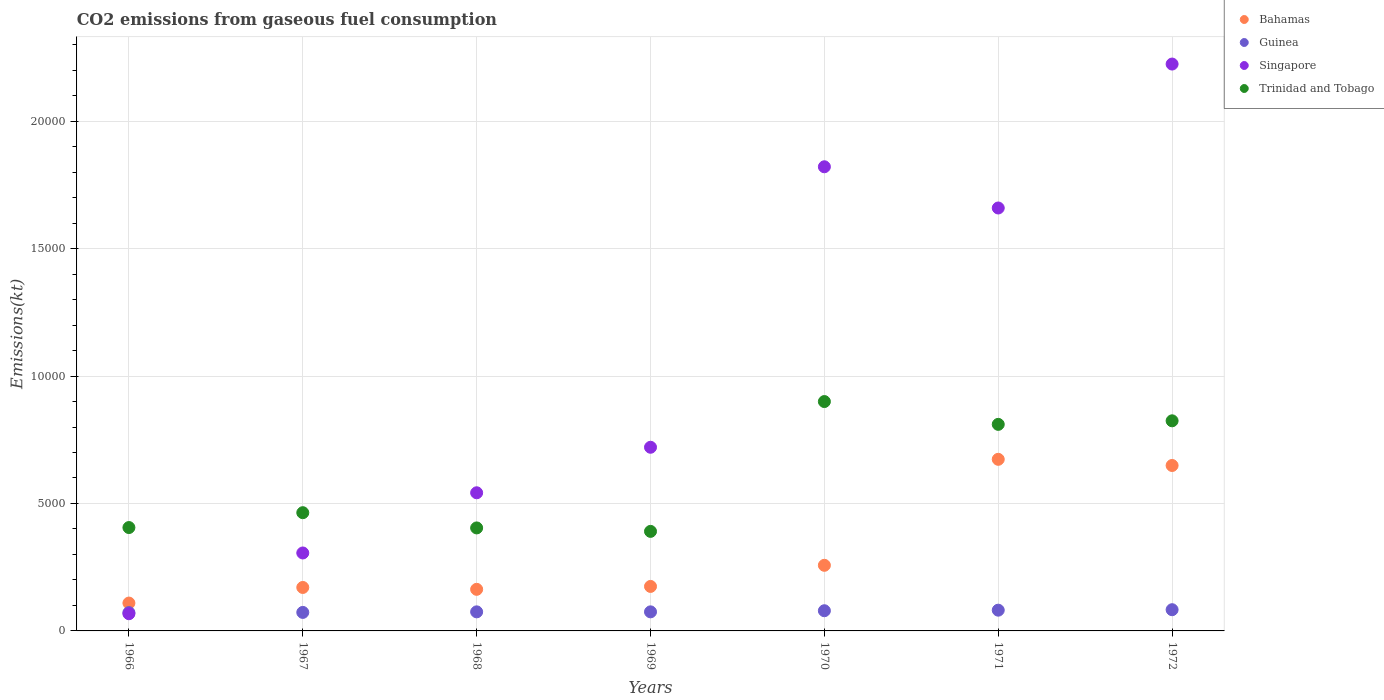How many different coloured dotlines are there?
Offer a very short reply. 4. Is the number of dotlines equal to the number of legend labels?
Offer a very short reply. Yes. What is the amount of CO2 emitted in Trinidad and Tobago in 1971?
Ensure brevity in your answer.  8104.07. Across all years, what is the maximum amount of CO2 emitted in Singapore?
Your answer should be compact. 2.22e+04. Across all years, what is the minimum amount of CO2 emitted in Singapore?
Ensure brevity in your answer.  674.73. In which year was the amount of CO2 emitted in Trinidad and Tobago minimum?
Provide a short and direct response. 1969. What is the total amount of CO2 emitted in Trinidad and Tobago in the graph?
Give a very brief answer. 4.20e+04. What is the difference between the amount of CO2 emitted in Bahamas in 1966 and that in 1971?
Give a very brief answer. -5639.85. What is the difference between the amount of CO2 emitted in Guinea in 1969 and the amount of CO2 emitted in Bahamas in 1967?
Give a very brief answer. -957.09. What is the average amount of CO2 emitted in Trinidad and Tobago per year?
Give a very brief answer. 5998.16. In the year 1970, what is the difference between the amount of CO2 emitted in Guinea and amount of CO2 emitted in Trinidad and Tobago?
Give a very brief answer. -8206.75. In how many years, is the amount of CO2 emitted in Bahamas greater than 19000 kt?
Your answer should be very brief. 0. What is the ratio of the amount of CO2 emitted in Guinea in 1966 to that in 1967?
Your response must be concise. 0.99. Is the amount of CO2 emitted in Trinidad and Tobago in 1968 less than that in 1970?
Give a very brief answer. Yes. Is the difference between the amount of CO2 emitted in Guinea in 1969 and 1971 greater than the difference between the amount of CO2 emitted in Trinidad and Tobago in 1969 and 1971?
Your answer should be very brief. Yes. What is the difference between the highest and the second highest amount of CO2 emitted in Trinidad and Tobago?
Ensure brevity in your answer.  755.4. What is the difference between the highest and the lowest amount of CO2 emitted in Singapore?
Provide a succinct answer. 2.16e+04. In how many years, is the amount of CO2 emitted in Guinea greater than the average amount of CO2 emitted in Guinea taken over all years?
Keep it short and to the point. 3. Is the sum of the amount of CO2 emitted in Singapore in 1970 and 1972 greater than the maximum amount of CO2 emitted in Trinidad and Tobago across all years?
Your response must be concise. Yes. Is it the case that in every year, the sum of the amount of CO2 emitted in Guinea and amount of CO2 emitted in Trinidad and Tobago  is greater than the sum of amount of CO2 emitted in Bahamas and amount of CO2 emitted in Singapore?
Your answer should be very brief. No. Is it the case that in every year, the sum of the amount of CO2 emitted in Bahamas and amount of CO2 emitted in Guinea  is greater than the amount of CO2 emitted in Singapore?
Ensure brevity in your answer.  No. Does the amount of CO2 emitted in Guinea monotonically increase over the years?
Make the answer very short. No. Is the amount of CO2 emitted in Trinidad and Tobago strictly greater than the amount of CO2 emitted in Bahamas over the years?
Your response must be concise. Yes. How many years are there in the graph?
Keep it short and to the point. 7. Does the graph contain grids?
Offer a terse response. Yes. Where does the legend appear in the graph?
Provide a short and direct response. Top right. What is the title of the graph?
Ensure brevity in your answer.  CO2 emissions from gaseous fuel consumption. Does "Sub-Saharan Africa (all income levels)" appear as one of the legend labels in the graph?
Provide a short and direct response. No. What is the label or title of the X-axis?
Make the answer very short. Years. What is the label or title of the Y-axis?
Your answer should be very brief. Emissions(kt). What is the Emissions(kt) in Bahamas in 1966?
Your answer should be compact. 1092.77. What is the Emissions(kt) in Guinea in 1966?
Your answer should be very brief. 718.73. What is the Emissions(kt) of Singapore in 1966?
Ensure brevity in your answer.  674.73. What is the Emissions(kt) of Trinidad and Tobago in 1966?
Ensure brevity in your answer.  4055.7. What is the Emissions(kt) in Bahamas in 1967?
Provide a succinct answer. 1705.15. What is the Emissions(kt) of Guinea in 1967?
Ensure brevity in your answer.  726.07. What is the Emissions(kt) of Singapore in 1967?
Make the answer very short. 3058.28. What is the Emissions(kt) of Trinidad and Tobago in 1967?
Offer a terse response. 4638.76. What is the Emissions(kt) in Bahamas in 1968?
Your answer should be very brief. 1631.82. What is the Emissions(kt) in Guinea in 1968?
Your answer should be very brief. 748.07. What is the Emissions(kt) of Singapore in 1968?
Your answer should be compact. 5419.83. What is the Emissions(kt) in Trinidad and Tobago in 1968?
Your response must be concise. 4041.03. What is the Emissions(kt) in Bahamas in 1969?
Offer a very short reply. 1745.49. What is the Emissions(kt) of Guinea in 1969?
Make the answer very short. 748.07. What is the Emissions(kt) in Singapore in 1969?
Ensure brevity in your answer.  7205.65. What is the Emissions(kt) of Trinidad and Tobago in 1969?
Provide a succinct answer. 3905.36. What is the Emissions(kt) of Bahamas in 1970?
Offer a terse response. 2574.23. What is the Emissions(kt) in Guinea in 1970?
Offer a very short reply. 792.07. What is the Emissions(kt) in Singapore in 1970?
Your response must be concise. 1.82e+04. What is the Emissions(kt) of Trinidad and Tobago in 1970?
Provide a short and direct response. 8998.82. What is the Emissions(kt) of Bahamas in 1971?
Your answer should be compact. 6732.61. What is the Emissions(kt) of Guinea in 1971?
Your answer should be very brief. 814.07. What is the Emissions(kt) in Singapore in 1971?
Offer a terse response. 1.66e+04. What is the Emissions(kt) of Trinidad and Tobago in 1971?
Make the answer very short. 8104.07. What is the Emissions(kt) in Bahamas in 1972?
Provide a short and direct response. 6490.59. What is the Emissions(kt) in Guinea in 1972?
Give a very brief answer. 832.41. What is the Emissions(kt) of Singapore in 1972?
Provide a short and direct response. 2.22e+04. What is the Emissions(kt) of Trinidad and Tobago in 1972?
Ensure brevity in your answer.  8243.42. Across all years, what is the maximum Emissions(kt) of Bahamas?
Your answer should be compact. 6732.61. Across all years, what is the maximum Emissions(kt) of Guinea?
Provide a succinct answer. 832.41. Across all years, what is the maximum Emissions(kt) in Singapore?
Offer a terse response. 2.22e+04. Across all years, what is the maximum Emissions(kt) of Trinidad and Tobago?
Provide a succinct answer. 8998.82. Across all years, what is the minimum Emissions(kt) of Bahamas?
Ensure brevity in your answer.  1092.77. Across all years, what is the minimum Emissions(kt) of Guinea?
Offer a terse response. 718.73. Across all years, what is the minimum Emissions(kt) of Singapore?
Your answer should be compact. 674.73. Across all years, what is the minimum Emissions(kt) of Trinidad and Tobago?
Make the answer very short. 3905.36. What is the total Emissions(kt) of Bahamas in the graph?
Keep it short and to the point. 2.20e+04. What is the total Emissions(kt) in Guinea in the graph?
Offer a very short reply. 5379.49. What is the total Emissions(kt) in Singapore in the graph?
Make the answer very short. 7.34e+04. What is the total Emissions(kt) of Trinidad and Tobago in the graph?
Offer a terse response. 4.20e+04. What is the difference between the Emissions(kt) of Bahamas in 1966 and that in 1967?
Offer a terse response. -612.39. What is the difference between the Emissions(kt) in Guinea in 1966 and that in 1967?
Provide a short and direct response. -7.33. What is the difference between the Emissions(kt) in Singapore in 1966 and that in 1967?
Offer a terse response. -2383.55. What is the difference between the Emissions(kt) of Trinidad and Tobago in 1966 and that in 1967?
Your answer should be compact. -583.05. What is the difference between the Emissions(kt) in Bahamas in 1966 and that in 1968?
Offer a terse response. -539.05. What is the difference between the Emissions(kt) of Guinea in 1966 and that in 1968?
Offer a very short reply. -29.34. What is the difference between the Emissions(kt) of Singapore in 1966 and that in 1968?
Provide a short and direct response. -4745.1. What is the difference between the Emissions(kt) of Trinidad and Tobago in 1966 and that in 1968?
Provide a succinct answer. 14.67. What is the difference between the Emissions(kt) of Bahamas in 1966 and that in 1969?
Provide a short and direct response. -652.73. What is the difference between the Emissions(kt) in Guinea in 1966 and that in 1969?
Ensure brevity in your answer.  -29.34. What is the difference between the Emissions(kt) in Singapore in 1966 and that in 1969?
Your answer should be very brief. -6530.93. What is the difference between the Emissions(kt) of Trinidad and Tobago in 1966 and that in 1969?
Give a very brief answer. 150.35. What is the difference between the Emissions(kt) in Bahamas in 1966 and that in 1970?
Offer a very short reply. -1481.47. What is the difference between the Emissions(kt) of Guinea in 1966 and that in 1970?
Give a very brief answer. -73.34. What is the difference between the Emissions(kt) in Singapore in 1966 and that in 1970?
Provide a succinct answer. -1.75e+04. What is the difference between the Emissions(kt) of Trinidad and Tobago in 1966 and that in 1970?
Ensure brevity in your answer.  -4943.12. What is the difference between the Emissions(kt) of Bahamas in 1966 and that in 1971?
Make the answer very short. -5639.85. What is the difference between the Emissions(kt) in Guinea in 1966 and that in 1971?
Keep it short and to the point. -95.34. What is the difference between the Emissions(kt) in Singapore in 1966 and that in 1971?
Offer a very short reply. -1.59e+04. What is the difference between the Emissions(kt) in Trinidad and Tobago in 1966 and that in 1971?
Ensure brevity in your answer.  -4048.37. What is the difference between the Emissions(kt) in Bahamas in 1966 and that in 1972?
Offer a very short reply. -5397.82. What is the difference between the Emissions(kt) in Guinea in 1966 and that in 1972?
Ensure brevity in your answer.  -113.68. What is the difference between the Emissions(kt) in Singapore in 1966 and that in 1972?
Your response must be concise. -2.16e+04. What is the difference between the Emissions(kt) in Trinidad and Tobago in 1966 and that in 1972?
Your answer should be compact. -4187.71. What is the difference between the Emissions(kt) in Bahamas in 1967 and that in 1968?
Ensure brevity in your answer.  73.34. What is the difference between the Emissions(kt) of Guinea in 1967 and that in 1968?
Provide a short and direct response. -22. What is the difference between the Emissions(kt) of Singapore in 1967 and that in 1968?
Your answer should be very brief. -2361.55. What is the difference between the Emissions(kt) in Trinidad and Tobago in 1967 and that in 1968?
Your answer should be very brief. 597.72. What is the difference between the Emissions(kt) of Bahamas in 1967 and that in 1969?
Make the answer very short. -40.34. What is the difference between the Emissions(kt) of Guinea in 1967 and that in 1969?
Offer a very short reply. -22. What is the difference between the Emissions(kt) of Singapore in 1967 and that in 1969?
Make the answer very short. -4147.38. What is the difference between the Emissions(kt) of Trinidad and Tobago in 1967 and that in 1969?
Your response must be concise. 733.4. What is the difference between the Emissions(kt) in Bahamas in 1967 and that in 1970?
Give a very brief answer. -869.08. What is the difference between the Emissions(kt) of Guinea in 1967 and that in 1970?
Your answer should be very brief. -66.01. What is the difference between the Emissions(kt) in Singapore in 1967 and that in 1970?
Offer a very short reply. -1.52e+04. What is the difference between the Emissions(kt) in Trinidad and Tobago in 1967 and that in 1970?
Provide a short and direct response. -4360.06. What is the difference between the Emissions(kt) in Bahamas in 1967 and that in 1971?
Provide a succinct answer. -5027.46. What is the difference between the Emissions(kt) in Guinea in 1967 and that in 1971?
Ensure brevity in your answer.  -88.01. What is the difference between the Emissions(kt) in Singapore in 1967 and that in 1971?
Your response must be concise. -1.35e+04. What is the difference between the Emissions(kt) of Trinidad and Tobago in 1967 and that in 1971?
Your answer should be very brief. -3465.32. What is the difference between the Emissions(kt) in Bahamas in 1967 and that in 1972?
Provide a short and direct response. -4785.44. What is the difference between the Emissions(kt) in Guinea in 1967 and that in 1972?
Your response must be concise. -106.34. What is the difference between the Emissions(kt) of Singapore in 1967 and that in 1972?
Provide a short and direct response. -1.92e+04. What is the difference between the Emissions(kt) of Trinidad and Tobago in 1967 and that in 1972?
Give a very brief answer. -3604.66. What is the difference between the Emissions(kt) in Bahamas in 1968 and that in 1969?
Make the answer very short. -113.68. What is the difference between the Emissions(kt) in Guinea in 1968 and that in 1969?
Keep it short and to the point. 0. What is the difference between the Emissions(kt) of Singapore in 1968 and that in 1969?
Ensure brevity in your answer.  -1785.83. What is the difference between the Emissions(kt) in Trinidad and Tobago in 1968 and that in 1969?
Keep it short and to the point. 135.68. What is the difference between the Emissions(kt) in Bahamas in 1968 and that in 1970?
Your answer should be compact. -942.42. What is the difference between the Emissions(kt) in Guinea in 1968 and that in 1970?
Keep it short and to the point. -44. What is the difference between the Emissions(kt) in Singapore in 1968 and that in 1970?
Your response must be concise. -1.28e+04. What is the difference between the Emissions(kt) of Trinidad and Tobago in 1968 and that in 1970?
Your answer should be compact. -4957.78. What is the difference between the Emissions(kt) in Bahamas in 1968 and that in 1971?
Your answer should be compact. -5100.8. What is the difference between the Emissions(kt) in Guinea in 1968 and that in 1971?
Make the answer very short. -66.01. What is the difference between the Emissions(kt) of Singapore in 1968 and that in 1971?
Your answer should be very brief. -1.12e+04. What is the difference between the Emissions(kt) in Trinidad and Tobago in 1968 and that in 1971?
Make the answer very short. -4063.04. What is the difference between the Emissions(kt) of Bahamas in 1968 and that in 1972?
Your answer should be very brief. -4858.77. What is the difference between the Emissions(kt) of Guinea in 1968 and that in 1972?
Ensure brevity in your answer.  -84.34. What is the difference between the Emissions(kt) of Singapore in 1968 and that in 1972?
Your answer should be very brief. -1.68e+04. What is the difference between the Emissions(kt) of Trinidad and Tobago in 1968 and that in 1972?
Keep it short and to the point. -4202.38. What is the difference between the Emissions(kt) of Bahamas in 1969 and that in 1970?
Give a very brief answer. -828.74. What is the difference between the Emissions(kt) of Guinea in 1969 and that in 1970?
Keep it short and to the point. -44. What is the difference between the Emissions(kt) of Singapore in 1969 and that in 1970?
Your response must be concise. -1.10e+04. What is the difference between the Emissions(kt) in Trinidad and Tobago in 1969 and that in 1970?
Your answer should be compact. -5093.46. What is the difference between the Emissions(kt) of Bahamas in 1969 and that in 1971?
Give a very brief answer. -4987.12. What is the difference between the Emissions(kt) of Guinea in 1969 and that in 1971?
Provide a succinct answer. -66.01. What is the difference between the Emissions(kt) in Singapore in 1969 and that in 1971?
Provide a succinct answer. -9387.52. What is the difference between the Emissions(kt) of Trinidad and Tobago in 1969 and that in 1971?
Offer a very short reply. -4198.72. What is the difference between the Emissions(kt) of Bahamas in 1969 and that in 1972?
Your answer should be compact. -4745.1. What is the difference between the Emissions(kt) of Guinea in 1969 and that in 1972?
Keep it short and to the point. -84.34. What is the difference between the Emissions(kt) of Singapore in 1969 and that in 1972?
Offer a terse response. -1.50e+04. What is the difference between the Emissions(kt) of Trinidad and Tobago in 1969 and that in 1972?
Your response must be concise. -4338.06. What is the difference between the Emissions(kt) of Bahamas in 1970 and that in 1971?
Offer a very short reply. -4158.38. What is the difference between the Emissions(kt) in Guinea in 1970 and that in 1971?
Make the answer very short. -22. What is the difference between the Emissions(kt) of Singapore in 1970 and that in 1971?
Your answer should be very brief. 1617.15. What is the difference between the Emissions(kt) of Trinidad and Tobago in 1970 and that in 1971?
Your answer should be very brief. 894.75. What is the difference between the Emissions(kt) of Bahamas in 1970 and that in 1972?
Your response must be concise. -3916.36. What is the difference between the Emissions(kt) in Guinea in 1970 and that in 1972?
Your response must be concise. -40.34. What is the difference between the Emissions(kt) of Singapore in 1970 and that in 1972?
Ensure brevity in your answer.  -4030.03. What is the difference between the Emissions(kt) of Trinidad and Tobago in 1970 and that in 1972?
Your answer should be compact. 755.4. What is the difference between the Emissions(kt) of Bahamas in 1971 and that in 1972?
Your response must be concise. 242.02. What is the difference between the Emissions(kt) in Guinea in 1971 and that in 1972?
Your answer should be compact. -18.34. What is the difference between the Emissions(kt) in Singapore in 1971 and that in 1972?
Provide a succinct answer. -5647.18. What is the difference between the Emissions(kt) in Trinidad and Tobago in 1971 and that in 1972?
Offer a very short reply. -139.35. What is the difference between the Emissions(kt) of Bahamas in 1966 and the Emissions(kt) of Guinea in 1967?
Make the answer very short. 366.7. What is the difference between the Emissions(kt) in Bahamas in 1966 and the Emissions(kt) in Singapore in 1967?
Provide a short and direct response. -1965.51. What is the difference between the Emissions(kt) in Bahamas in 1966 and the Emissions(kt) in Trinidad and Tobago in 1967?
Ensure brevity in your answer.  -3545.99. What is the difference between the Emissions(kt) in Guinea in 1966 and the Emissions(kt) in Singapore in 1967?
Provide a short and direct response. -2339.55. What is the difference between the Emissions(kt) in Guinea in 1966 and the Emissions(kt) in Trinidad and Tobago in 1967?
Make the answer very short. -3920.02. What is the difference between the Emissions(kt) of Singapore in 1966 and the Emissions(kt) of Trinidad and Tobago in 1967?
Give a very brief answer. -3964.03. What is the difference between the Emissions(kt) of Bahamas in 1966 and the Emissions(kt) of Guinea in 1968?
Make the answer very short. 344.7. What is the difference between the Emissions(kt) in Bahamas in 1966 and the Emissions(kt) in Singapore in 1968?
Offer a very short reply. -4327.06. What is the difference between the Emissions(kt) of Bahamas in 1966 and the Emissions(kt) of Trinidad and Tobago in 1968?
Your answer should be very brief. -2948.27. What is the difference between the Emissions(kt) of Guinea in 1966 and the Emissions(kt) of Singapore in 1968?
Provide a short and direct response. -4701.09. What is the difference between the Emissions(kt) of Guinea in 1966 and the Emissions(kt) of Trinidad and Tobago in 1968?
Your answer should be compact. -3322.3. What is the difference between the Emissions(kt) in Singapore in 1966 and the Emissions(kt) in Trinidad and Tobago in 1968?
Your response must be concise. -3366.31. What is the difference between the Emissions(kt) of Bahamas in 1966 and the Emissions(kt) of Guinea in 1969?
Offer a very short reply. 344.7. What is the difference between the Emissions(kt) in Bahamas in 1966 and the Emissions(kt) in Singapore in 1969?
Your answer should be very brief. -6112.89. What is the difference between the Emissions(kt) of Bahamas in 1966 and the Emissions(kt) of Trinidad and Tobago in 1969?
Your answer should be compact. -2812.59. What is the difference between the Emissions(kt) in Guinea in 1966 and the Emissions(kt) in Singapore in 1969?
Ensure brevity in your answer.  -6486.92. What is the difference between the Emissions(kt) of Guinea in 1966 and the Emissions(kt) of Trinidad and Tobago in 1969?
Offer a terse response. -3186.62. What is the difference between the Emissions(kt) in Singapore in 1966 and the Emissions(kt) in Trinidad and Tobago in 1969?
Your answer should be very brief. -3230.63. What is the difference between the Emissions(kt) of Bahamas in 1966 and the Emissions(kt) of Guinea in 1970?
Your answer should be very brief. 300.69. What is the difference between the Emissions(kt) of Bahamas in 1966 and the Emissions(kt) of Singapore in 1970?
Give a very brief answer. -1.71e+04. What is the difference between the Emissions(kt) of Bahamas in 1966 and the Emissions(kt) of Trinidad and Tobago in 1970?
Ensure brevity in your answer.  -7906.05. What is the difference between the Emissions(kt) in Guinea in 1966 and the Emissions(kt) in Singapore in 1970?
Provide a short and direct response. -1.75e+04. What is the difference between the Emissions(kt) in Guinea in 1966 and the Emissions(kt) in Trinidad and Tobago in 1970?
Offer a very short reply. -8280.09. What is the difference between the Emissions(kt) in Singapore in 1966 and the Emissions(kt) in Trinidad and Tobago in 1970?
Provide a succinct answer. -8324.09. What is the difference between the Emissions(kt) in Bahamas in 1966 and the Emissions(kt) in Guinea in 1971?
Offer a terse response. 278.69. What is the difference between the Emissions(kt) of Bahamas in 1966 and the Emissions(kt) of Singapore in 1971?
Your response must be concise. -1.55e+04. What is the difference between the Emissions(kt) of Bahamas in 1966 and the Emissions(kt) of Trinidad and Tobago in 1971?
Make the answer very short. -7011.3. What is the difference between the Emissions(kt) in Guinea in 1966 and the Emissions(kt) in Singapore in 1971?
Make the answer very short. -1.59e+04. What is the difference between the Emissions(kt) in Guinea in 1966 and the Emissions(kt) in Trinidad and Tobago in 1971?
Keep it short and to the point. -7385.34. What is the difference between the Emissions(kt) in Singapore in 1966 and the Emissions(kt) in Trinidad and Tobago in 1971?
Make the answer very short. -7429.34. What is the difference between the Emissions(kt) in Bahamas in 1966 and the Emissions(kt) in Guinea in 1972?
Provide a succinct answer. 260.36. What is the difference between the Emissions(kt) in Bahamas in 1966 and the Emissions(kt) in Singapore in 1972?
Provide a short and direct response. -2.11e+04. What is the difference between the Emissions(kt) of Bahamas in 1966 and the Emissions(kt) of Trinidad and Tobago in 1972?
Offer a very short reply. -7150.65. What is the difference between the Emissions(kt) in Guinea in 1966 and the Emissions(kt) in Singapore in 1972?
Offer a very short reply. -2.15e+04. What is the difference between the Emissions(kt) of Guinea in 1966 and the Emissions(kt) of Trinidad and Tobago in 1972?
Keep it short and to the point. -7524.68. What is the difference between the Emissions(kt) of Singapore in 1966 and the Emissions(kt) of Trinidad and Tobago in 1972?
Offer a terse response. -7568.69. What is the difference between the Emissions(kt) in Bahamas in 1967 and the Emissions(kt) in Guinea in 1968?
Your answer should be very brief. 957.09. What is the difference between the Emissions(kt) in Bahamas in 1967 and the Emissions(kt) in Singapore in 1968?
Offer a very short reply. -3714.67. What is the difference between the Emissions(kt) of Bahamas in 1967 and the Emissions(kt) of Trinidad and Tobago in 1968?
Keep it short and to the point. -2335.88. What is the difference between the Emissions(kt) in Guinea in 1967 and the Emissions(kt) in Singapore in 1968?
Ensure brevity in your answer.  -4693.76. What is the difference between the Emissions(kt) of Guinea in 1967 and the Emissions(kt) of Trinidad and Tobago in 1968?
Offer a very short reply. -3314.97. What is the difference between the Emissions(kt) in Singapore in 1967 and the Emissions(kt) in Trinidad and Tobago in 1968?
Give a very brief answer. -982.76. What is the difference between the Emissions(kt) in Bahamas in 1967 and the Emissions(kt) in Guinea in 1969?
Your answer should be very brief. 957.09. What is the difference between the Emissions(kt) of Bahamas in 1967 and the Emissions(kt) of Singapore in 1969?
Provide a short and direct response. -5500.5. What is the difference between the Emissions(kt) of Bahamas in 1967 and the Emissions(kt) of Trinidad and Tobago in 1969?
Ensure brevity in your answer.  -2200.2. What is the difference between the Emissions(kt) in Guinea in 1967 and the Emissions(kt) in Singapore in 1969?
Provide a succinct answer. -6479.59. What is the difference between the Emissions(kt) in Guinea in 1967 and the Emissions(kt) in Trinidad and Tobago in 1969?
Offer a very short reply. -3179.29. What is the difference between the Emissions(kt) in Singapore in 1967 and the Emissions(kt) in Trinidad and Tobago in 1969?
Keep it short and to the point. -847.08. What is the difference between the Emissions(kt) of Bahamas in 1967 and the Emissions(kt) of Guinea in 1970?
Ensure brevity in your answer.  913.08. What is the difference between the Emissions(kt) in Bahamas in 1967 and the Emissions(kt) in Singapore in 1970?
Provide a short and direct response. -1.65e+04. What is the difference between the Emissions(kt) in Bahamas in 1967 and the Emissions(kt) in Trinidad and Tobago in 1970?
Your answer should be very brief. -7293.66. What is the difference between the Emissions(kt) in Guinea in 1967 and the Emissions(kt) in Singapore in 1970?
Keep it short and to the point. -1.75e+04. What is the difference between the Emissions(kt) of Guinea in 1967 and the Emissions(kt) of Trinidad and Tobago in 1970?
Give a very brief answer. -8272.75. What is the difference between the Emissions(kt) of Singapore in 1967 and the Emissions(kt) of Trinidad and Tobago in 1970?
Ensure brevity in your answer.  -5940.54. What is the difference between the Emissions(kt) of Bahamas in 1967 and the Emissions(kt) of Guinea in 1971?
Give a very brief answer. 891.08. What is the difference between the Emissions(kt) of Bahamas in 1967 and the Emissions(kt) of Singapore in 1971?
Provide a short and direct response. -1.49e+04. What is the difference between the Emissions(kt) in Bahamas in 1967 and the Emissions(kt) in Trinidad and Tobago in 1971?
Your response must be concise. -6398.91. What is the difference between the Emissions(kt) in Guinea in 1967 and the Emissions(kt) in Singapore in 1971?
Your response must be concise. -1.59e+04. What is the difference between the Emissions(kt) in Guinea in 1967 and the Emissions(kt) in Trinidad and Tobago in 1971?
Offer a terse response. -7378. What is the difference between the Emissions(kt) in Singapore in 1967 and the Emissions(kt) in Trinidad and Tobago in 1971?
Your answer should be very brief. -5045.79. What is the difference between the Emissions(kt) of Bahamas in 1967 and the Emissions(kt) of Guinea in 1972?
Provide a short and direct response. 872.75. What is the difference between the Emissions(kt) of Bahamas in 1967 and the Emissions(kt) of Singapore in 1972?
Offer a very short reply. -2.05e+04. What is the difference between the Emissions(kt) in Bahamas in 1967 and the Emissions(kt) in Trinidad and Tobago in 1972?
Make the answer very short. -6538.26. What is the difference between the Emissions(kt) of Guinea in 1967 and the Emissions(kt) of Singapore in 1972?
Your answer should be very brief. -2.15e+04. What is the difference between the Emissions(kt) in Guinea in 1967 and the Emissions(kt) in Trinidad and Tobago in 1972?
Make the answer very short. -7517.35. What is the difference between the Emissions(kt) of Singapore in 1967 and the Emissions(kt) of Trinidad and Tobago in 1972?
Keep it short and to the point. -5185.14. What is the difference between the Emissions(kt) of Bahamas in 1968 and the Emissions(kt) of Guinea in 1969?
Offer a terse response. 883.75. What is the difference between the Emissions(kt) of Bahamas in 1968 and the Emissions(kt) of Singapore in 1969?
Offer a terse response. -5573.84. What is the difference between the Emissions(kt) of Bahamas in 1968 and the Emissions(kt) of Trinidad and Tobago in 1969?
Make the answer very short. -2273.54. What is the difference between the Emissions(kt) in Guinea in 1968 and the Emissions(kt) in Singapore in 1969?
Provide a short and direct response. -6457.59. What is the difference between the Emissions(kt) of Guinea in 1968 and the Emissions(kt) of Trinidad and Tobago in 1969?
Your answer should be compact. -3157.29. What is the difference between the Emissions(kt) in Singapore in 1968 and the Emissions(kt) in Trinidad and Tobago in 1969?
Provide a short and direct response. 1514.47. What is the difference between the Emissions(kt) of Bahamas in 1968 and the Emissions(kt) of Guinea in 1970?
Your response must be concise. 839.74. What is the difference between the Emissions(kt) in Bahamas in 1968 and the Emissions(kt) in Singapore in 1970?
Your response must be concise. -1.66e+04. What is the difference between the Emissions(kt) in Bahamas in 1968 and the Emissions(kt) in Trinidad and Tobago in 1970?
Provide a short and direct response. -7367. What is the difference between the Emissions(kt) in Guinea in 1968 and the Emissions(kt) in Singapore in 1970?
Make the answer very short. -1.75e+04. What is the difference between the Emissions(kt) in Guinea in 1968 and the Emissions(kt) in Trinidad and Tobago in 1970?
Make the answer very short. -8250.75. What is the difference between the Emissions(kt) of Singapore in 1968 and the Emissions(kt) of Trinidad and Tobago in 1970?
Ensure brevity in your answer.  -3578.99. What is the difference between the Emissions(kt) in Bahamas in 1968 and the Emissions(kt) in Guinea in 1971?
Ensure brevity in your answer.  817.74. What is the difference between the Emissions(kt) of Bahamas in 1968 and the Emissions(kt) of Singapore in 1971?
Provide a succinct answer. -1.50e+04. What is the difference between the Emissions(kt) in Bahamas in 1968 and the Emissions(kt) in Trinidad and Tobago in 1971?
Provide a succinct answer. -6472.26. What is the difference between the Emissions(kt) of Guinea in 1968 and the Emissions(kt) of Singapore in 1971?
Give a very brief answer. -1.58e+04. What is the difference between the Emissions(kt) of Guinea in 1968 and the Emissions(kt) of Trinidad and Tobago in 1971?
Keep it short and to the point. -7356. What is the difference between the Emissions(kt) in Singapore in 1968 and the Emissions(kt) in Trinidad and Tobago in 1971?
Make the answer very short. -2684.24. What is the difference between the Emissions(kt) in Bahamas in 1968 and the Emissions(kt) in Guinea in 1972?
Your answer should be very brief. 799.41. What is the difference between the Emissions(kt) of Bahamas in 1968 and the Emissions(kt) of Singapore in 1972?
Give a very brief answer. -2.06e+04. What is the difference between the Emissions(kt) of Bahamas in 1968 and the Emissions(kt) of Trinidad and Tobago in 1972?
Make the answer very short. -6611.6. What is the difference between the Emissions(kt) of Guinea in 1968 and the Emissions(kt) of Singapore in 1972?
Keep it short and to the point. -2.15e+04. What is the difference between the Emissions(kt) in Guinea in 1968 and the Emissions(kt) in Trinidad and Tobago in 1972?
Provide a succinct answer. -7495.35. What is the difference between the Emissions(kt) of Singapore in 1968 and the Emissions(kt) of Trinidad and Tobago in 1972?
Offer a terse response. -2823.59. What is the difference between the Emissions(kt) of Bahamas in 1969 and the Emissions(kt) of Guinea in 1970?
Keep it short and to the point. 953.42. What is the difference between the Emissions(kt) of Bahamas in 1969 and the Emissions(kt) of Singapore in 1970?
Keep it short and to the point. -1.65e+04. What is the difference between the Emissions(kt) in Bahamas in 1969 and the Emissions(kt) in Trinidad and Tobago in 1970?
Make the answer very short. -7253.33. What is the difference between the Emissions(kt) in Guinea in 1969 and the Emissions(kt) in Singapore in 1970?
Offer a very short reply. -1.75e+04. What is the difference between the Emissions(kt) of Guinea in 1969 and the Emissions(kt) of Trinidad and Tobago in 1970?
Ensure brevity in your answer.  -8250.75. What is the difference between the Emissions(kt) in Singapore in 1969 and the Emissions(kt) in Trinidad and Tobago in 1970?
Keep it short and to the point. -1793.16. What is the difference between the Emissions(kt) in Bahamas in 1969 and the Emissions(kt) in Guinea in 1971?
Ensure brevity in your answer.  931.42. What is the difference between the Emissions(kt) of Bahamas in 1969 and the Emissions(kt) of Singapore in 1971?
Offer a terse response. -1.48e+04. What is the difference between the Emissions(kt) in Bahamas in 1969 and the Emissions(kt) in Trinidad and Tobago in 1971?
Offer a very short reply. -6358.58. What is the difference between the Emissions(kt) of Guinea in 1969 and the Emissions(kt) of Singapore in 1971?
Make the answer very short. -1.58e+04. What is the difference between the Emissions(kt) in Guinea in 1969 and the Emissions(kt) in Trinidad and Tobago in 1971?
Provide a short and direct response. -7356. What is the difference between the Emissions(kt) in Singapore in 1969 and the Emissions(kt) in Trinidad and Tobago in 1971?
Your response must be concise. -898.41. What is the difference between the Emissions(kt) in Bahamas in 1969 and the Emissions(kt) in Guinea in 1972?
Give a very brief answer. 913.08. What is the difference between the Emissions(kt) of Bahamas in 1969 and the Emissions(kt) of Singapore in 1972?
Ensure brevity in your answer.  -2.05e+04. What is the difference between the Emissions(kt) in Bahamas in 1969 and the Emissions(kt) in Trinidad and Tobago in 1972?
Offer a very short reply. -6497.92. What is the difference between the Emissions(kt) of Guinea in 1969 and the Emissions(kt) of Singapore in 1972?
Make the answer very short. -2.15e+04. What is the difference between the Emissions(kt) of Guinea in 1969 and the Emissions(kt) of Trinidad and Tobago in 1972?
Your answer should be very brief. -7495.35. What is the difference between the Emissions(kt) in Singapore in 1969 and the Emissions(kt) in Trinidad and Tobago in 1972?
Your response must be concise. -1037.76. What is the difference between the Emissions(kt) in Bahamas in 1970 and the Emissions(kt) in Guinea in 1971?
Offer a terse response. 1760.16. What is the difference between the Emissions(kt) in Bahamas in 1970 and the Emissions(kt) in Singapore in 1971?
Make the answer very short. -1.40e+04. What is the difference between the Emissions(kt) of Bahamas in 1970 and the Emissions(kt) of Trinidad and Tobago in 1971?
Offer a very short reply. -5529.84. What is the difference between the Emissions(kt) of Guinea in 1970 and the Emissions(kt) of Singapore in 1971?
Offer a terse response. -1.58e+04. What is the difference between the Emissions(kt) of Guinea in 1970 and the Emissions(kt) of Trinidad and Tobago in 1971?
Offer a very short reply. -7312. What is the difference between the Emissions(kt) in Singapore in 1970 and the Emissions(kt) in Trinidad and Tobago in 1971?
Make the answer very short. 1.01e+04. What is the difference between the Emissions(kt) of Bahamas in 1970 and the Emissions(kt) of Guinea in 1972?
Ensure brevity in your answer.  1741.83. What is the difference between the Emissions(kt) of Bahamas in 1970 and the Emissions(kt) of Singapore in 1972?
Offer a very short reply. -1.97e+04. What is the difference between the Emissions(kt) of Bahamas in 1970 and the Emissions(kt) of Trinidad and Tobago in 1972?
Offer a very short reply. -5669.18. What is the difference between the Emissions(kt) of Guinea in 1970 and the Emissions(kt) of Singapore in 1972?
Your response must be concise. -2.14e+04. What is the difference between the Emissions(kt) of Guinea in 1970 and the Emissions(kt) of Trinidad and Tobago in 1972?
Provide a short and direct response. -7451.34. What is the difference between the Emissions(kt) in Singapore in 1970 and the Emissions(kt) in Trinidad and Tobago in 1972?
Provide a short and direct response. 9966.91. What is the difference between the Emissions(kt) in Bahamas in 1971 and the Emissions(kt) in Guinea in 1972?
Give a very brief answer. 5900.2. What is the difference between the Emissions(kt) in Bahamas in 1971 and the Emissions(kt) in Singapore in 1972?
Keep it short and to the point. -1.55e+04. What is the difference between the Emissions(kt) in Bahamas in 1971 and the Emissions(kt) in Trinidad and Tobago in 1972?
Provide a short and direct response. -1510.8. What is the difference between the Emissions(kt) in Guinea in 1971 and the Emissions(kt) in Singapore in 1972?
Provide a succinct answer. -2.14e+04. What is the difference between the Emissions(kt) in Guinea in 1971 and the Emissions(kt) in Trinidad and Tobago in 1972?
Your answer should be compact. -7429.34. What is the difference between the Emissions(kt) of Singapore in 1971 and the Emissions(kt) of Trinidad and Tobago in 1972?
Ensure brevity in your answer.  8349.76. What is the average Emissions(kt) in Bahamas per year?
Give a very brief answer. 3138.95. What is the average Emissions(kt) in Guinea per year?
Offer a terse response. 768.5. What is the average Emissions(kt) of Singapore per year?
Offer a terse response. 1.05e+04. What is the average Emissions(kt) of Trinidad and Tobago per year?
Your response must be concise. 5998.16. In the year 1966, what is the difference between the Emissions(kt) in Bahamas and Emissions(kt) in Guinea?
Ensure brevity in your answer.  374.03. In the year 1966, what is the difference between the Emissions(kt) in Bahamas and Emissions(kt) in Singapore?
Your answer should be compact. 418.04. In the year 1966, what is the difference between the Emissions(kt) of Bahamas and Emissions(kt) of Trinidad and Tobago?
Your answer should be very brief. -2962.94. In the year 1966, what is the difference between the Emissions(kt) of Guinea and Emissions(kt) of Singapore?
Make the answer very short. 44. In the year 1966, what is the difference between the Emissions(kt) in Guinea and Emissions(kt) in Trinidad and Tobago?
Your answer should be very brief. -3336.97. In the year 1966, what is the difference between the Emissions(kt) of Singapore and Emissions(kt) of Trinidad and Tobago?
Make the answer very short. -3380.97. In the year 1967, what is the difference between the Emissions(kt) in Bahamas and Emissions(kt) in Guinea?
Give a very brief answer. 979.09. In the year 1967, what is the difference between the Emissions(kt) of Bahamas and Emissions(kt) of Singapore?
Offer a very short reply. -1353.12. In the year 1967, what is the difference between the Emissions(kt) of Bahamas and Emissions(kt) of Trinidad and Tobago?
Keep it short and to the point. -2933.6. In the year 1967, what is the difference between the Emissions(kt) in Guinea and Emissions(kt) in Singapore?
Provide a short and direct response. -2332.21. In the year 1967, what is the difference between the Emissions(kt) in Guinea and Emissions(kt) in Trinidad and Tobago?
Make the answer very short. -3912.69. In the year 1967, what is the difference between the Emissions(kt) of Singapore and Emissions(kt) of Trinidad and Tobago?
Make the answer very short. -1580.48. In the year 1968, what is the difference between the Emissions(kt) in Bahamas and Emissions(kt) in Guinea?
Provide a succinct answer. 883.75. In the year 1968, what is the difference between the Emissions(kt) in Bahamas and Emissions(kt) in Singapore?
Provide a short and direct response. -3788.01. In the year 1968, what is the difference between the Emissions(kt) of Bahamas and Emissions(kt) of Trinidad and Tobago?
Give a very brief answer. -2409.22. In the year 1968, what is the difference between the Emissions(kt) in Guinea and Emissions(kt) in Singapore?
Provide a short and direct response. -4671.76. In the year 1968, what is the difference between the Emissions(kt) of Guinea and Emissions(kt) of Trinidad and Tobago?
Your answer should be compact. -3292.97. In the year 1968, what is the difference between the Emissions(kt) of Singapore and Emissions(kt) of Trinidad and Tobago?
Offer a terse response. 1378.79. In the year 1969, what is the difference between the Emissions(kt) of Bahamas and Emissions(kt) of Guinea?
Your response must be concise. 997.42. In the year 1969, what is the difference between the Emissions(kt) in Bahamas and Emissions(kt) in Singapore?
Give a very brief answer. -5460.16. In the year 1969, what is the difference between the Emissions(kt) of Bahamas and Emissions(kt) of Trinidad and Tobago?
Ensure brevity in your answer.  -2159.86. In the year 1969, what is the difference between the Emissions(kt) of Guinea and Emissions(kt) of Singapore?
Your response must be concise. -6457.59. In the year 1969, what is the difference between the Emissions(kt) in Guinea and Emissions(kt) in Trinidad and Tobago?
Offer a very short reply. -3157.29. In the year 1969, what is the difference between the Emissions(kt) of Singapore and Emissions(kt) of Trinidad and Tobago?
Your response must be concise. 3300.3. In the year 1970, what is the difference between the Emissions(kt) of Bahamas and Emissions(kt) of Guinea?
Ensure brevity in your answer.  1782.16. In the year 1970, what is the difference between the Emissions(kt) of Bahamas and Emissions(kt) of Singapore?
Your response must be concise. -1.56e+04. In the year 1970, what is the difference between the Emissions(kt) in Bahamas and Emissions(kt) in Trinidad and Tobago?
Your answer should be compact. -6424.58. In the year 1970, what is the difference between the Emissions(kt) of Guinea and Emissions(kt) of Singapore?
Offer a terse response. -1.74e+04. In the year 1970, what is the difference between the Emissions(kt) of Guinea and Emissions(kt) of Trinidad and Tobago?
Provide a succinct answer. -8206.75. In the year 1970, what is the difference between the Emissions(kt) in Singapore and Emissions(kt) in Trinidad and Tobago?
Ensure brevity in your answer.  9211.5. In the year 1971, what is the difference between the Emissions(kt) of Bahamas and Emissions(kt) of Guinea?
Offer a very short reply. 5918.54. In the year 1971, what is the difference between the Emissions(kt) in Bahamas and Emissions(kt) in Singapore?
Give a very brief answer. -9860.56. In the year 1971, what is the difference between the Emissions(kt) of Bahamas and Emissions(kt) of Trinidad and Tobago?
Your answer should be compact. -1371.46. In the year 1971, what is the difference between the Emissions(kt) in Guinea and Emissions(kt) in Singapore?
Make the answer very short. -1.58e+04. In the year 1971, what is the difference between the Emissions(kt) in Guinea and Emissions(kt) in Trinidad and Tobago?
Offer a terse response. -7290. In the year 1971, what is the difference between the Emissions(kt) of Singapore and Emissions(kt) of Trinidad and Tobago?
Offer a very short reply. 8489.1. In the year 1972, what is the difference between the Emissions(kt) of Bahamas and Emissions(kt) of Guinea?
Give a very brief answer. 5658.18. In the year 1972, what is the difference between the Emissions(kt) of Bahamas and Emissions(kt) of Singapore?
Offer a very short reply. -1.57e+04. In the year 1972, what is the difference between the Emissions(kt) of Bahamas and Emissions(kt) of Trinidad and Tobago?
Provide a succinct answer. -1752.83. In the year 1972, what is the difference between the Emissions(kt) in Guinea and Emissions(kt) in Singapore?
Offer a very short reply. -2.14e+04. In the year 1972, what is the difference between the Emissions(kt) of Guinea and Emissions(kt) of Trinidad and Tobago?
Offer a very short reply. -7411.01. In the year 1972, what is the difference between the Emissions(kt) of Singapore and Emissions(kt) of Trinidad and Tobago?
Provide a succinct answer. 1.40e+04. What is the ratio of the Emissions(kt) in Bahamas in 1966 to that in 1967?
Offer a terse response. 0.64. What is the ratio of the Emissions(kt) of Singapore in 1966 to that in 1967?
Your answer should be compact. 0.22. What is the ratio of the Emissions(kt) in Trinidad and Tobago in 1966 to that in 1967?
Keep it short and to the point. 0.87. What is the ratio of the Emissions(kt) of Bahamas in 1966 to that in 1968?
Keep it short and to the point. 0.67. What is the ratio of the Emissions(kt) of Guinea in 1966 to that in 1968?
Give a very brief answer. 0.96. What is the ratio of the Emissions(kt) of Singapore in 1966 to that in 1968?
Give a very brief answer. 0.12. What is the ratio of the Emissions(kt) in Trinidad and Tobago in 1966 to that in 1968?
Your answer should be compact. 1. What is the ratio of the Emissions(kt) of Bahamas in 1966 to that in 1969?
Your answer should be compact. 0.63. What is the ratio of the Emissions(kt) in Guinea in 1966 to that in 1969?
Ensure brevity in your answer.  0.96. What is the ratio of the Emissions(kt) of Singapore in 1966 to that in 1969?
Ensure brevity in your answer.  0.09. What is the ratio of the Emissions(kt) in Trinidad and Tobago in 1966 to that in 1969?
Your answer should be very brief. 1.04. What is the ratio of the Emissions(kt) in Bahamas in 1966 to that in 1970?
Keep it short and to the point. 0.42. What is the ratio of the Emissions(kt) in Guinea in 1966 to that in 1970?
Make the answer very short. 0.91. What is the ratio of the Emissions(kt) of Singapore in 1966 to that in 1970?
Provide a short and direct response. 0.04. What is the ratio of the Emissions(kt) of Trinidad and Tobago in 1966 to that in 1970?
Your answer should be very brief. 0.45. What is the ratio of the Emissions(kt) of Bahamas in 1966 to that in 1971?
Make the answer very short. 0.16. What is the ratio of the Emissions(kt) of Guinea in 1966 to that in 1971?
Offer a terse response. 0.88. What is the ratio of the Emissions(kt) of Singapore in 1966 to that in 1971?
Offer a terse response. 0.04. What is the ratio of the Emissions(kt) of Trinidad and Tobago in 1966 to that in 1971?
Your answer should be very brief. 0.5. What is the ratio of the Emissions(kt) of Bahamas in 1966 to that in 1972?
Offer a terse response. 0.17. What is the ratio of the Emissions(kt) in Guinea in 1966 to that in 1972?
Your answer should be compact. 0.86. What is the ratio of the Emissions(kt) of Singapore in 1966 to that in 1972?
Provide a succinct answer. 0.03. What is the ratio of the Emissions(kt) of Trinidad and Tobago in 1966 to that in 1972?
Provide a short and direct response. 0.49. What is the ratio of the Emissions(kt) of Bahamas in 1967 to that in 1968?
Provide a short and direct response. 1.04. What is the ratio of the Emissions(kt) of Guinea in 1967 to that in 1968?
Offer a very short reply. 0.97. What is the ratio of the Emissions(kt) of Singapore in 1967 to that in 1968?
Give a very brief answer. 0.56. What is the ratio of the Emissions(kt) in Trinidad and Tobago in 1967 to that in 1968?
Your answer should be compact. 1.15. What is the ratio of the Emissions(kt) in Bahamas in 1967 to that in 1969?
Your response must be concise. 0.98. What is the ratio of the Emissions(kt) of Guinea in 1967 to that in 1969?
Provide a short and direct response. 0.97. What is the ratio of the Emissions(kt) of Singapore in 1967 to that in 1969?
Your answer should be compact. 0.42. What is the ratio of the Emissions(kt) in Trinidad and Tobago in 1967 to that in 1969?
Keep it short and to the point. 1.19. What is the ratio of the Emissions(kt) in Bahamas in 1967 to that in 1970?
Keep it short and to the point. 0.66. What is the ratio of the Emissions(kt) of Singapore in 1967 to that in 1970?
Make the answer very short. 0.17. What is the ratio of the Emissions(kt) in Trinidad and Tobago in 1967 to that in 1970?
Provide a succinct answer. 0.52. What is the ratio of the Emissions(kt) of Bahamas in 1967 to that in 1971?
Your answer should be very brief. 0.25. What is the ratio of the Emissions(kt) of Guinea in 1967 to that in 1971?
Offer a terse response. 0.89. What is the ratio of the Emissions(kt) of Singapore in 1967 to that in 1971?
Your answer should be compact. 0.18. What is the ratio of the Emissions(kt) of Trinidad and Tobago in 1967 to that in 1971?
Provide a succinct answer. 0.57. What is the ratio of the Emissions(kt) of Bahamas in 1967 to that in 1972?
Your response must be concise. 0.26. What is the ratio of the Emissions(kt) in Guinea in 1967 to that in 1972?
Your answer should be very brief. 0.87. What is the ratio of the Emissions(kt) of Singapore in 1967 to that in 1972?
Provide a short and direct response. 0.14. What is the ratio of the Emissions(kt) of Trinidad and Tobago in 1967 to that in 1972?
Keep it short and to the point. 0.56. What is the ratio of the Emissions(kt) in Bahamas in 1968 to that in 1969?
Your answer should be very brief. 0.93. What is the ratio of the Emissions(kt) of Guinea in 1968 to that in 1969?
Your answer should be compact. 1. What is the ratio of the Emissions(kt) of Singapore in 1968 to that in 1969?
Your answer should be very brief. 0.75. What is the ratio of the Emissions(kt) in Trinidad and Tobago in 1968 to that in 1969?
Your answer should be compact. 1.03. What is the ratio of the Emissions(kt) of Bahamas in 1968 to that in 1970?
Your answer should be compact. 0.63. What is the ratio of the Emissions(kt) in Guinea in 1968 to that in 1970?
Make the answer very short. 0.94. What is the ratio of the Emissions(kt) in Singapore in 1968 to that in 1970?
Your answer should be very brief. 0.3. What is the ratio of the Emissions(kt) in Trinidad and Tobago in 1968 to that in 1970?
Provide a short and direct response. 0.45. What is the ratio of the Emissions(kt) in Bahamas in 1968 to that in 1971?
Make the answer very short. 0.24. What is the ratio of the Emissions(kt) of Guinea in 1968 to that in 1971?
Ensure brevity in your answer.  0.92. What is the ratio of the Emissions(kt) in Singapore in 1968 to that in 1971?
Offer a very short reply. 0.33. What is the ratio of the Emissions(kt) in Trinidad and Tobago in 1968 to that in 1971?
Your answer should be very brief. 0.5. What is the ratio of the Emissions(kt) in Bahamas in 1968 to that in 1972?
Give a very brief answer. 0.25. What is the ratio of the Emissions(kt) of Guinea in 1968 to that in 1972?
Ensure brevity in your answer.  0.9. What is the ratio of the Emissions(kt) in Singapore in 1968 to that in 1972?
Offer a terse response. 0.24. What is the ratio of the Emissions(kt) of Trinidad and Tobago in 1968 to that in 1972?
Your response must be concise. 0.49. What is the ratio of the Emissions(kt) of Bahamas in 1969 to that in 1970?
Your answer should be very brief. 0.68. What is the ratio of the Emissions(kt) in Guinea in 1969 to that in 1970?
Keep it short and to the point. 0.94. What is the ratio of the Emissions(kt) in Singapore in 1969 to that in 1970?
Your response must be concise. 0.4. What is the ratio of the Emissions(kt) in Trinidad and Tobago in 1969 to that in 1970?
Keep it short and to the point. 0.43. What is the ratio of the Emissions(kt) in Bahamas in 1969 to that in 1971?
Make the answer very short. 0.26. What is the ratio of the Emissions(kt) of Guinea in 1969 to that in 1971?
Make the answer very short. 0.92. What is the ratio of the Emissions(kt) of Singapore in 1969 to that in 1971?
Make the answer very short. 0.43. What is the ratio of the Emissions(kt) in Trinidad and Tobago in 1969 to that in 1971?
Offer a terse response. 0.48. What is the ratio of the Emissions(kt) in Bahamas in 1969 to that in 1972?
Offer a very short reply. 0.27. What is the ratio of the Emissions(kt) of Guinea in 1969 to that in 1972?
Your response must be concise. 0.9. What is the ratio of the Emissions(kt) in Singapore in 1969 to that in 1972?
Your answer should be compact. 0.32. What is the ratio of the Emissions(kt) of Trinidad and Tobago in 1969 to that in 1972?
Ensure brevity in your answer.  0.47. What is the ratio of the Emissions(kt) of Bahamas in 1970 to that in 1971?
Provide a succinct answer. 0.38. What is the ratio of the Emissions(kt) in Singapore in 1970 to that in 1971?
Provide a succinct answer. 1.1. What is the ratio of the Emissions(kt) of Trinidad and Tobago in 1970 to that in 1971?
Ensure brevity in your answer.  1.11. What is the ratio of the Emissions(kt) in Bahamas in 1970 to that in 1972?
Your response must be concise. 0.4. What is the ratio of the Emissions(kt) in Guinea in 1970 to that in 1972?
Your response must be concise. 0.95. What is the ratio of the Emissions(kt) in Singapore in 1970 to that in 1972?
Provide a succinct answer. 0.82. What is the ratio of the Emissions(kt) of Trinidad and Tobago in 1970 to that in 1972?
Your answer should be very brief. 1.09. What is the ratio of the Emissions(kt) of Bahamas in 1971 to that in 1972?
Keep it short and to the point. 1.04. What is the ratio of the Emissions(kt) in Guinea in 1971 to that in 1972?
Offer a very short reply. 0.98. What is the ratio of the Emissions(kt) in Singapore in 1971 to that in 1972?
Your answer should be very brief. 0.75. What is the ratio of the Emissions(kt) of Trinidad and Tobago in 1971 to that in 1972?
Your answer should be very brief. 0.98. What is the difference between the highest and the second highest Emissions(kt) in Bahamas?
Your answer should be compact. 242.02. What is the difference between the highest and the second highest Emissions(kt) in Guinea?
Offer a very short reply. 18.34. What is the difference between the highest and the second highest Emissions(kt) in Singapore?
Give a very brief answer. 4030.03. What is the difference between the highest and the second highest Emissions(kt) of Trinidad and Tobago?
Make the answer very short. 755.4. What is the difference between the highest and the lowest Emissions(kt) in Bahamas?
Offer a terse response. 5639.85. What is the difference between the highest and the lowest Emissions(kt) in Guinea?
Make the answer very short. 113.68. What is the difference between the highest and the lowest Emissions(kt) of Singapore?
Provide a short and direct response. 2.16e+04. What is the difference between the highest and the lowest Emissions(kt) of Trinidad and Tobago?
Your answer should be compact. 5093.46. 